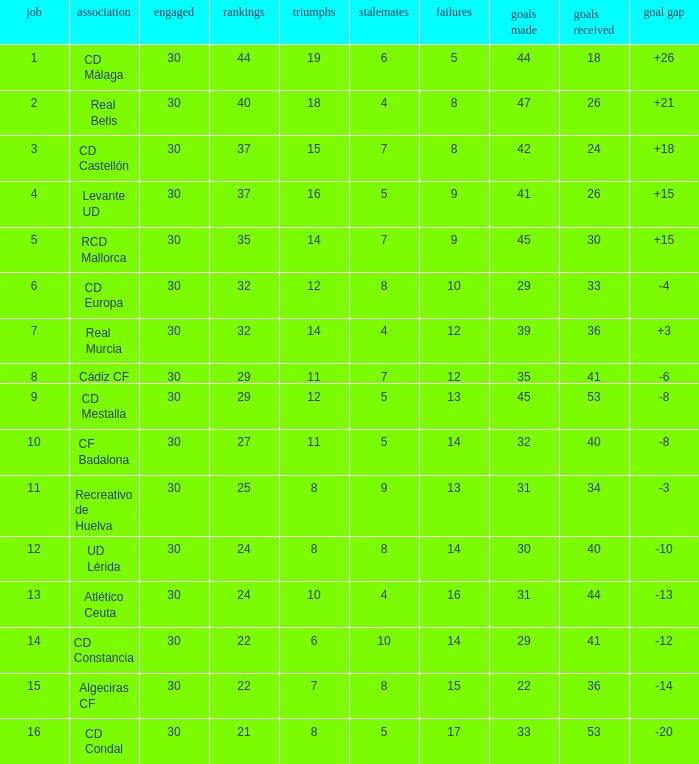What is the number of losses when the goal difference was -8, and position is smaller than 10? 1.0. 